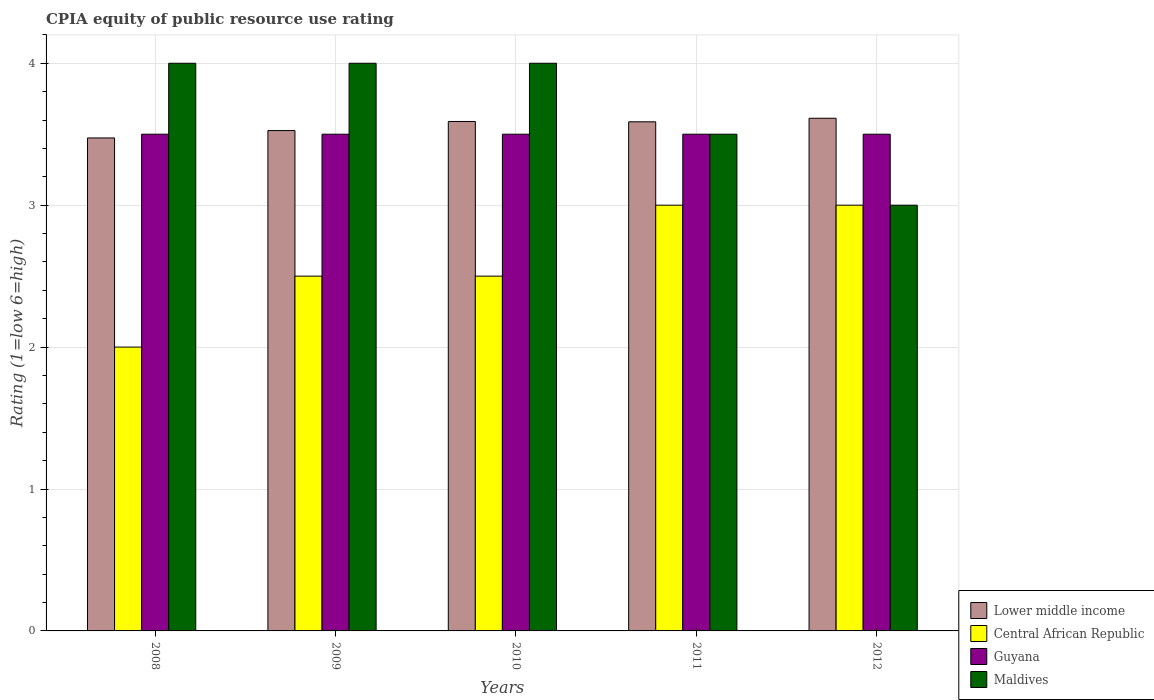How many different coloured bars are there?
Make the answer very short. 4. What is the label of the 1st group of bars from the left?
Offer a very short reply. 2008. In how many cases, is the number of bars for a given year not equal to the number of legend labels?
Give a very brief answer. 0. Across all years, what is the minimum CPIA rating in Guyana?
Provide a short and direct response. 3.5. What is the difference between the CPIA rating in Central African Republic in 2010 and the CPIA rating in Maldives in 2009?
Provide a succinct answer. -1.5. What is the average CPIA rating in Lower middle income per year?
Offer a terse response. 3.56. In the year 2012, what is the difference between the CPIA rating in Lower middle income and CPIA rating in Guyana?
Keep it short and to the point. 0.11. What is the ratio of the CPIA rating in Lower middle income in 2009 to that in 2012?
Provide a short and direct response. 0.98. Is the CPIA rating in Lower middle income in 2008 less than that in 2009?
Your response must be concise. Yes. Is the difference between the CPIA rating in Lower middle income in 2010 and 2012 greater than the difference between the CPIA rating in Guyana in 2010 and 2012?
Your answer should be compact. No. What does the 1st bar from the left in 2012 represents?
Keep it short and to the point. Lower middle income. What does the 1st bar from the right in 2011 represents?
Your response must be concise. Maldives. How many bars are there?
Ensure brevity in your answer.  20. Are all the bars in the graph horizontal?
Your answer should be compact. No. How many years are there in the graph?
Provide a short and direct response. 5. What is the difference between two consecutive major ticks on the Y-axis?
Offer a very short reply. 1. How many legend labels are there?
Your answer should be compact. 4. How are the legend labels stacked?
Offer a terse response. Vertical. What is the title of the graph?
Offer a very short reply. CPIA equity of public resource use rating. What is the label or title of the X-axis?
Provide a short and direct response. Years. What is the label or title of the Y-axis?
Your answer should be very brief. Rating (1=low 6=high). What is the Rating (1=low 6=high) in Lower middle income in 2008?
Provide a succinct answer. 3.47. What is the Rating (1=low 6=high) of Central African Republic in 2008?
Offer a terse response. 2. What is the Rating (1=low 6=high) in Guyana in 2008?
Offer a very short reply. 3.5. What is the Rating (1=low 6=high) in Lower middle income in 2009?
Your response must be concise. 3.53. What is the Rating (1=low 6=high) in Lower middle income in 2010?
Your answer should be very brief. 3.59. What is the Rating (1=low 6=high) in Central African Republic in 2010?
Provide a short and direct response. 2.5. What is the Rating (1=low 6=high) of Guyana in 2010?
Give a very brief answer. 3.5. What is the Rating (1=low 6=high) in Lower middle income in 2011?
Provide a short and direct response. 3.59. What is the Rating (1=low 6=high) in Central African Republic in 2011?
Ensure brevity in your answer.  3. What is the Rating (1=low 6=high) in Lower middle income in 2012?
Offer a very short reply. 3.61. What is the Rating (1=low 6=high) in Central African Republic in 2012?
Offer a terse response. 3. What is the Rating (1=low 6=high) of Guyana in 2012?
Offer a terse response. 3.5. Across all years, what is the maximum Rating (1=low 6=high) of Lower middle income?
Offer a terse response. 3.61. Across all years, what is the maximum Rating (1=low 6=high) in Central African Republic?
Give a very brief answer. 3. Across all years, what is the maximum Rating (1=low 6=high) in Guyana?
Offer a terse response. 3.5. Across all years, what is the maximum Rating (1=low 6=high) in Maldives?
Your answer should be very brief. 4. Across all years, what is the minimum Rating (1=low 6=high) of Lower middle income?
Provide a short and direct response. 3.47. Across all years, what is the minimum Rating (1=low 6=high) in Central African Republic?
Offer a very short reply. 2. Across all years, what is the minimum Rating (1=low 6=high) in Maldives?
Keep it short and to the point. 3. What is the total Rating (1=low 6=high) of Lower middle income in the graph?
Give a very brief answer. 17.79. What is the total Rating (1=low 6=high) of Central African Republic in the graph?
Make the answer very short. 13. What is the total Rating (1=low 6=high) in Guyana in the graph?
Provide a short and direct response. 17.5. What is the total Rating (1=low 6=high) in Maldives in the graph?
Ensure brevity in your answer.  18.5. What is the difference between the Rating (1=low 6=high) in Lower middle income in 2008 and that in 2009?
Offer a terse response. -0.05. What is the difference between the Rating (1=low 6=high) in Central African Republic in 2008 and that in 2009?
Keep it short and to the point. -0.5. What is the difference between the Rating (1=low 6=high) in Lower middle income in 2008 and that in 2010?
Give a very brief answer. -0.12. What is the difference between the Rating (1=low 6=high) of Central African Republic in 2008 and that in 2010?
Your answer should be very brief. -0.5. What is the difference between the Rating (1=low 6=high) of Guyana in 2008 and that in 2010?
Offer a terse response. 0. What is the difference between the Rating (1=low 6=high) of Lower middle income in 2008 and that in 2011?
Give a very brief answer. -0.11. What is the difference between the Rating (1=low 6=high) in Central African Republic in 2008 and that in 2011?
Your answer should be compact. -1. What is the difference between the Rating (1=low 6=high) of Lower middle income in 2008 and that in 2012?
Your answer should be compact. -0.14. What is the difference between the Rating (1=low 6=high) of Central African Republic in 2008 and that in 2012?
Offer a very short reply. -1. What is the difference between the Rating (1=low 6=high) of Lower middle income in 2009 and that in 2010?
Give a very brief answer. -0.06. What is the difference between the Rating (1=low 6=high) of Central African Republic in 2009 and that in 2010?
Provide a short and direct response. 0. What is the difference between the Rating (1=low 6=high) in Guyana in 2009 and that in 2010?
Your answer should be compact. 0. What is the difference between the Rating (1=low 6=high) of Maldives in 2009 and that in 2010?
Provide a short and direct response. 0. What is the difference between the Rating (1=low 6=high) of Lower middle income in 2009 and that in 2011?
Your answer should be compact. -0.06. What is the difference between the Rating (1=low 6=high) in Maldives in 2009 and that in 2011?
Your response must be concise. 0.5. What is the difference between the Rating (1=low 6=high) in Lower middle income in 2009 and that in 2012?
Your response must be concise. -0.09. What is the difference between the Rating (1=low 6=high) in Central African Republic in 2009 and that in 2012?
Offer a very short reply. -0.5. What is the difference between the Rating (1=low 6=high) in Lower middle income in 2010 and that in 2011?
Your answer should be very brief. 0. What is the difference between the Rating (1=low 6=high) of Lower middle income in 2010 and that in 2012?
Offer a terse response. -0.02. What is the difference between the Rating (1=low 6=high) of Central African Republic in 2010 and that in 2012?
Offer a very short reply. -0.5. What is the difference between the Rating (1=low 6=high) of Lower middle income in 2011 and that in 2012?
Keep it short and to the point. -0.03. What is the difference between the Rating (1=low 6=high) of Central African Republic in 2011 and that in 2012?
Offer a very short reply. 0. What is the difference between the Rating (1=low 6=high) in Lower middle income in 2008 and the Rating (1=low 6=high) in Central African Republic in 2009?
Provide a succinct answer. 0.97. What is the difference between the Rating (1=low 6=high) in Lower middle income in 2008 and the Rating (1=low 6=high) in Guyana in 2009?
Your response must be concise. -0.03. What is the difference between the Rating (1=low 6=high) of Lower middle income in 2008 and the Rating (1=low 6=high) of Maldives in 2009?
Keep it short and to the point. -0.53. What is the difference between the Rating (1=low 6=high) of Central African Republic in 2008 and the Rating (1=low 6=high) of Guyana in 2009?
Provide a succinct answer. -1.5. What is the difference between the Rating (1=low 6=high) of Central African Republic in 2008 and the Rating (1=low 6=high) of Maldives in 2009?
Give a very brief answer. -2. What is the difference between the Rating (1=low 6=high) in Guyana in 2008 and the Rating (1=low 6=high) in Maldives in 2009?
Keep it short and to the point. -0.5. What is the difference between the Rating (1=low 6=high) in Lower middle income in 2008 and the Rating (1=low 6=high) in Central African Republic in 2010?
Give a very brief answer. 0.97. What is the difference between the Rating (1=low 6=high) of Lower middle income in 2008 and the Rating (1=low 6=high) of Guyana in 2010?
Make the answer very short. -0.03. What is the difference between the Rating (1=low 6=high) in Lower middle income in 2008 and the Rating (1=low 6=high) in Maldives in 2010?
Ensure brevity in your answer.  -0.53. What is the difference between the Rating (1=low 6=high) of Central African Republic in 2008 and the Rating (1=low 6=high) of Guyana in 2010?
Make the answer very short. -1.5. What is the difference between the Rating (1=low 6=high) in Guyana in 2008 and the Rating (1=low 6=high) in Maldives in 2010?
Keep it short and to the point. -0.5. What is the difference between the Rating (1=low 6=high) of Lower middle income in 2008 and the Rating (1=low 6=high) of Central African Republic in 2011?
Offer a very short reply. 0.47. What is the difference between the Rating (1=low 6=high) in Lower middle income in 2008 and the Rating (1=low 6=high) in Guyana in 2011?
Give a very brief answer. -0.03. What is the difference between the Rating (1=low 6=high) of Lower middle income in 2008 and the Rating (1=low 6=high) of Maldives in 2011?
Keep it short and to the point. -0.03. What is the difference between the Rating (1=low 6=high) in Central African Republic in 2008 and the Rating (1=low 6=high) in Maldives in 2011?
Make the answer very short. -1.5. What is the difference between the Rating (1=low 6=high) of Guyana in 2008 and the Rating (1=low 6=high) of Maldives in 2011?
Make the answer very short. 0. What is the difference between the Rating (1=low 6=high) of Lower middle income in 2008 and the Rating (1=low 6=high) of Central African Republic in 2012?
Offer a very short reply. 0.47. What is the difference between the Rating (1=low 6=high) of Lower middle income in 2008 and the Rating (1=low 6=high) of Guyana in 2012?
Ensure brevity in your answer.  -0.03. What is the difference between the Rating (1=low 6=high) in Lower middle income in 2008 and the Rating (1=low 6=high) in Maldives in 2012?
Make the answer very short. 0.47. What is the difference between the Rating (1=low 6=high) in Central African Republic in 2008 and the Rating (1=low 6=high) in Maldives in 2012?
Your response must be concise. -1. What is the difference between the Rating (1=low 6=high) in Lower middle income in 2009 and the Rating (1=low 6=high) in Central African Republic in 2010?
Provide a succinct answer. 1.03. What is the difference between the Rating (1=low 6=high) of Lower middle income in 2009 and the Rating (1=low 6=high) of Guyana in 2010?
Give a very brief answer. 0.03. What is the difference between the Rating (1=low 6=high) of Lower middle income in 2009 and the Rating (1=low 6=high) of Maldives in 2010?
Keep it short and to the point. -0.47. What is the difference between the Rating (1=low 6=high) in Central African Republic in 2009 and the Rating (1=low 6=high) in Guyana in 2010?
Your answer should be compact. -1. What is the difference between the Rating (1=low 6=high) in Central African Republic in 2009 and the Rating (1=low 6=high) in Maldives in 2010?
Keep it short and to the point. -1.5. What is the difference between the Rating (1=low 6=high) in Guyana in 2009 and the Rating (1=low 6=high) in Maldives in 2010?
Your answer should be very brief. -0.5. What is the difference between the Rating (1=low 6=high) in Lower middle income in 2009 and the Rating (1=low 6=high) in Central African Republic in 2011?
Provide a succinct answer. 0.53. What is the difference between the Rating (1=low 6=high) of Lower middle income in 2009 and the Rating (1=low 6=high) of Guyana in 2011?
Provide a succinct answer. 0.03. What is the difference between the Rating (1=low 6=high) in Lower middle income in 2009 and the Rating (1=low 6=high) in Maldives in 2011?
Offer a terse response. 0.03. What is the difference between the Rating (1=low 6=high) in Central African Republic in 2009 and the Rating (1=low 6=high) in Guyana in 2011?
Your answer should be very brief. -1. What is the difference between the Rating (1=low 6=high) in Central African Republic in 2009 and the Rating (1=low 6=high) in Maldives in 2011?
Your answer should be compact. -1. What is the difference between the Rating (1=low 6=high) in Guyana in 2009 and the Rating (1=low 6=high) in Maldives in 2011?
Make the answer very short. 0. What is the difference between the Rating (1=low 6=high) in Lower middle income in 2009 and the Rating (1=low 6=high) in Central African Republic in 2012?
Your answer should be compact. 0.53. What is the difference between the Rating (1=low 6=high) of Lower middle income in 2009 and the Rating (1=low 6=high) of Guyana in 2012?
Provide a short and direct response. 0.03. What is the difference between the Rating (1=low 6=high) in Lower middle income in 2009 and the Rating (1=low 6=high) in Maldives in 2012?
Provide a succinct answer. 0.53. What is the difference between the Rating (1=low 6=high) of Central African Republic in 2009 and the Rating (1=low 6=high) of Guyana in 2012?
Your answer should be very brief. -1. What is the difference between the Rating (1=low 6=high) of Guyana in 2009 and the Rating (1=low 6=high) of Maldives in 2012?
Offer a very short reply. 0.5. What is the difference between the Rating (1=low 6=high) in Lower middle income in 2010 and the Rating (1=low 6=high) in Central African Republic in 2011?
Provide a short and direct response. 0.59. What is the difference between the Rating (1=low 6=high) in Lower middle income in 2010 and the Rating (1=low 6=high) in Guyana in 2011?
Your answer should be very brief. 0.09. What is the difference between the Rating (1=low 6=high) of Lower middle income in 2010 and the Rating (1=low 6=high) of Maldives in 2011?
Provide a short and direct response. 0.09. What is the difference between the Rating (1=low 6=high) in Central African Republic in 2010 and the Rating (1=low 6=high) in Maldives in 2011?
Make the answer very short. -1. What is the difference between the Rating (1=low 6=high) of Guyana in 2010 and the Rating (1=low 6=high) of Maldives in 2011?
Offer a very short reply. 0. What is the difference between the Rating (1=low 6=high) in Lower middle income in 2010 and the Rating (1=low 6=high) in Central African Republic in 2012?
Make the answer very short. 0.59. What is the difference between the Rating (1=low 6=high) in Lower middle income in 2010 and the Rating (1=low 6=high) in Guyana in 2012?
Keep it short and to the point. 0.09. What is the difference between the Rating (1=low 6=high) in Lower middle income in 2010 and the Rating (1=low 6=high) in Maldives in 2012?
Offer a very short reply. 0.59. What is the difference between the Rating (1=low 6=high) of Central African Republic in 2010 and the Rating (1=low 6=high) of Guyana in 2012?
Keep it short and to the point. -1. What is the difference between the Rating (1=low 6=high) in Central African Republic in 2010 and the Rating (1=low 6=high) in Maldives in 2012?
Your response must be concise. -0.5. What is the difference between the Rating (1=low 6=high) in Guyana in 2010 and the Rating (1=low 6=high) in Maldives in 2012?
Keep it short and to the point. 0.5. What is the difference between the Rating (1=low 6=high) in Lower middle income in 2011 and the Rating (1=low 6=high) in Central African Republic in 2012?
Ensure brevity in your answer.  0.59. What is the difference between the Rating (1=low 6=high) of Lower middle income in 2011 and the Rating (1=low 6=high) of Guyana in 2012?
Provide a short and direct response. 0.09. What is the difference between the Rating (1=low 6=high) of Lower middle income in 2011 and the Rating (1=low 6=high) of Maldives in 2012?
Make the answer very short. 0.59. What is the difference between the Rating (1=low 6=high) in Central African Republic in 2011 and the Rating (1=low 6=high) in Guyana in 2012?
Offer a very short reply. -0.5. What is the difference between the Rating (1=low 6=high) in Guyana in 2011 and the Rating (1=low 6=high) in Maldives in 2012?
Ensure brevity in your answer.  0.5. What is the average Rating (1=low 6=high) in Lower middle income per year?
Offer a very short reply. 3.56. What is the average Rating (1=low 6=high) in Central African Republic per year?
Provide a succinct answer. 2.6. What is the average Rating (1=low 6=high) in Guyana per year?
Offer a very short reply. 3.5. What is the average Rating (1=low 6=high) of Maldives per year?
Provide a succinct answer. 3.7. In the year 2008, what is the difference between the Rating (1=low 6=high) of Lower middle income and Rating (1=low 6=high) of Central African Republic?
Offer a very short reply. 1.47. In the year 2008, what is the difference between the Rating (1=low 6=high) in Lower middle income and Rating (1=low 6=high) in Guyana?
Make the answer very short. -0.03. In the year 2008, what is the difference between the Rating (1=low 6=high) in Lower middle income and Rating (1=low 6=high) in Maldives?
Ensure brevity in your answer.  -0.53. In the year 2008, what is the difference between the Rating (1=low 6=high) in Central African Republic and Rating (1=low 6=high) in Guyana?
Ensure brevity in your answer.  -1.5. In the year 2009, what is the difference between the Rating (1=low 6=high) of Lower middle income and Rating (1=low 6=high) of Central African Republic?
Ensure brevity in your answer.  1.03. In the year 2009, what is the difference between the Rating (1=low 6=high) of Lower middle income and Rating (1=low 6=high) of Guyana?
Ensure brevity in your answer.  0.03. In the year 2009, what is the difference between the Rating (1=low 6=high) in Lower middle income and Rating (1=low 6=high) in Maldives?
Give a very brief answer. -0.47. In the year 2009, what is the difference between the Rating (1=low 6=high) in Central African Republic and Rating (1=low 6=high) in Maldives?
Keep it short and to the point. -1.5. In the year 2009, what is the difference between the Rating (1=low 6=high) in Guyana and Rating (1=low 6=high) in Maldives?
Make the answer very short. -0.5. In the year 2010, what is the difference between the Rating (1=low 6=high) of Lower middle income and Rating (1=low 6=high) of Central African Republic?
Offer a terse response. 1.09. In the year 2010, what is the difference between the Rating (1=low 6=high) of Lower middle income and Rating (1=low 6=high) of Guyana?
Your answer should be compact. 0.09. In the year 2010, what is the difference between the Rating (1=low 6=high) in Lower middle income and Rating (1=low 6=high) in Maldives?
Your response must be concise. -0.41. In the year 2010, what is the difference between the Rating (1=low 6=high) in Central African Republic and Rating (1=low 6=high) in Maldives?
Your answer should be very brief. -1.5. In the year 2011, what is the difference between the Rating (1=low 6=high) in Lower middle income and Rating (1=low 6=high) in Central African Republic?
Give a very brief answer. 0.59. In the year 2011, what is the difference between the Rating (1=low 6=high) of Lower middle income and Rating (1=low 6=high) of Guyana?
Your answer should be very brief. 0.09. In the year 2011, what is the difference between the Rating (1=low 6=high) of Lower middle income and Rating (1=low 6=high) of Maldives?
Give a very brief answer. 0.09. In the year 2011, what is the difference between the Rating (1=low 6=high) of Guyana and Rating (1=low 6=high) of Maldives?
Make the answer very short. 0. In the year 2012, what is the difference between the Rating (1=low 6=high) of Lower middle income and Rating (1=low 6=high) of Central African Republic?
Your answer should be very brief. 0.61. In the year 2012, what is the difference between the Rating (1=low 6=high) of Lower middle income and Rating (1=low 6=high) of Guyana?
Make the answer very short. 0.11. In the year 2012, what is the difference between the Rating (1=low 6=high) of Lower middle income and Rating (1=low 6=high) of Maldives?
Ensure brevity in your answer.  0.61. What is the ratio of the Rating (1=low 6=high) of Lower middle income in 2008 to that in 2009?
Offer a terse response. 0.99. What is the ratio of the Rating (1=low 6=high) of Central African Republic in 2008 to that in 2009?
Your answer should be very brief. 0.8. What is the ratio of the Rating (1=low 6=high) in Central African Republic in 2008 to that in 2010?
Ensure brevity in your answer.  0.8. What is the ratio of the Rating (1=low 6=high) of Guyana in 2008 to that in 2010?
Ensure brevity in your answer.  1. What is the ratio of the Rating (1=low 6=high) in Lower middle income in 2008 to that in 2011?
Your answer should be compact. 0.97. What is the ratio of the Rating (1=low 6=high) in Guyana in 2008 to that in 2011?
Make the answer very short. 1. What is the ratio of the Rating (1=low 6=high) of Maldives in 2008 to that in 2011?
Ensure brevity in your answer.  1.14. What is the ratio of the Rating (1=low 6=high) in Lower middle income in 2008 to that in 2012?
Your answer should be very brief. 0.96. What is the ratio of the Rating (1=low 6=high) of Lower middle income in 2009 to that in 2010?
Offer a very short reply. 0.98. What is the ratio of the Rating (1=low 6=high) in Lower middle income in 2009 to that in 2011?
Offer a very short reply. 0.98. What is the ratio of the Rating (1=low 6=high) in Central African Republic in 2009 to that in 2011?
Keep it short and to the point. 0.83. What is the ratio of the Rating (1=low 6=high) of Guyana in 2009 to that in 2011?
Your response must be concise. 1. What is the ratio of the Rating (1=low 6=high) of Lower middle income in 2009 to that in 2012?
Provide a short and direct response. 0.98. What is the ratio of the Rating (1=low 6=high) in Lower middle income in 2010 to that in 2011?
Keep it short and to the point. 1. What is the ratio of the Rating (1=low 6=high) in Central African Republic in 2010 to that in 2011?
Your response must be concise. 0.83. What is the ratio of the Rating (1=low 6=high) of Maldives in 2010 to that in 2011?
Give a very brief answer. 1.14. What is the ratio of the Rating (1=low 6=high) in Central African Republic in 2010 to that in 2012?
Make the answer very short. 0.83. What is the difference between the highest and the second highest Rating (1=low 6=high) in Lower middle income?
Your response must be concise. 0.02. What is the difference between the highest and the second highest Rating (1=low 6=high) of Central African Republic?
Ensure brevity in your answer.  0. What is the difference between the highest and the second highest Rating (1=low 6=high) of Guyana?
Your answer should be compact. 0. What is the difference between the highest and the lowest Rating (1=low 6=high) of Lower middle income?
Offer a terse response. 0.14. 